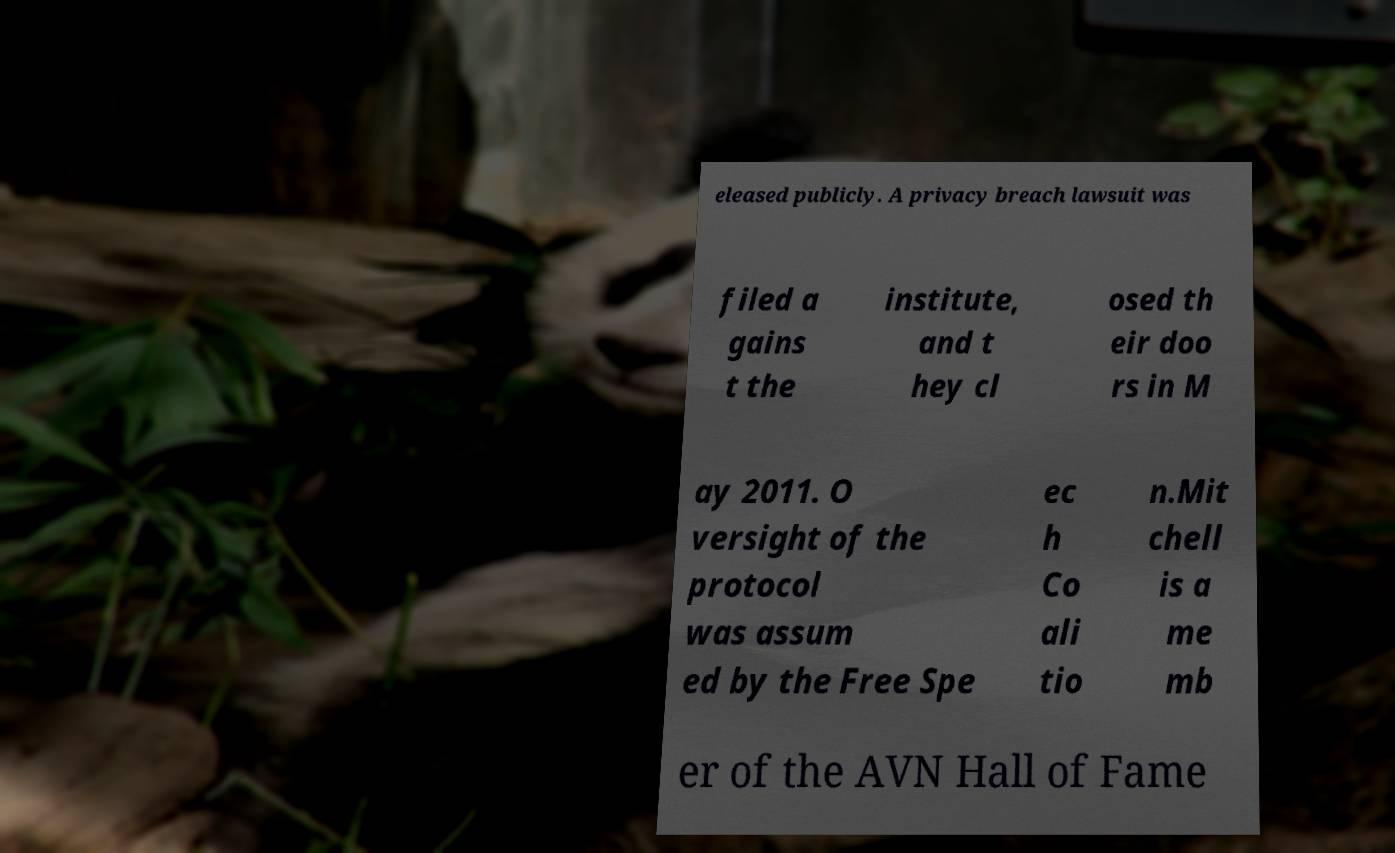Can you read and provide the text displayed in the image?This photo seems to have some interesting text. Can you extract and type it out for me? eleased publicly. A privacy breach lawsuit was filed a gains t the institute, and t hey cl osed th eir doo rs in M ay 2011. O versight of the protocol was assum ed by the Free Spe ec h Co ali tio n.Mit chell is a me mb er of the AVN Hall of Fame 